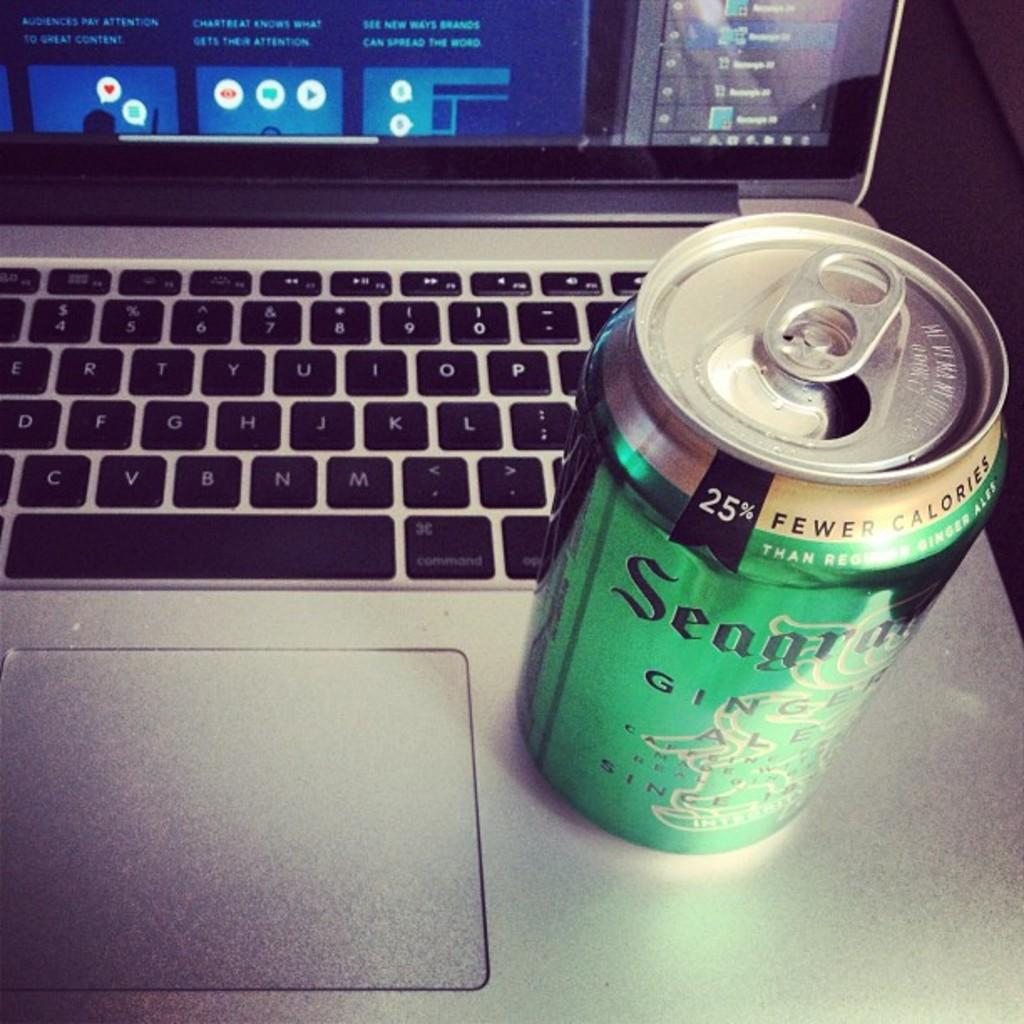Provide a one-sentence caption for the provided image. A laptop with a largely green can of ginger ale on it. 